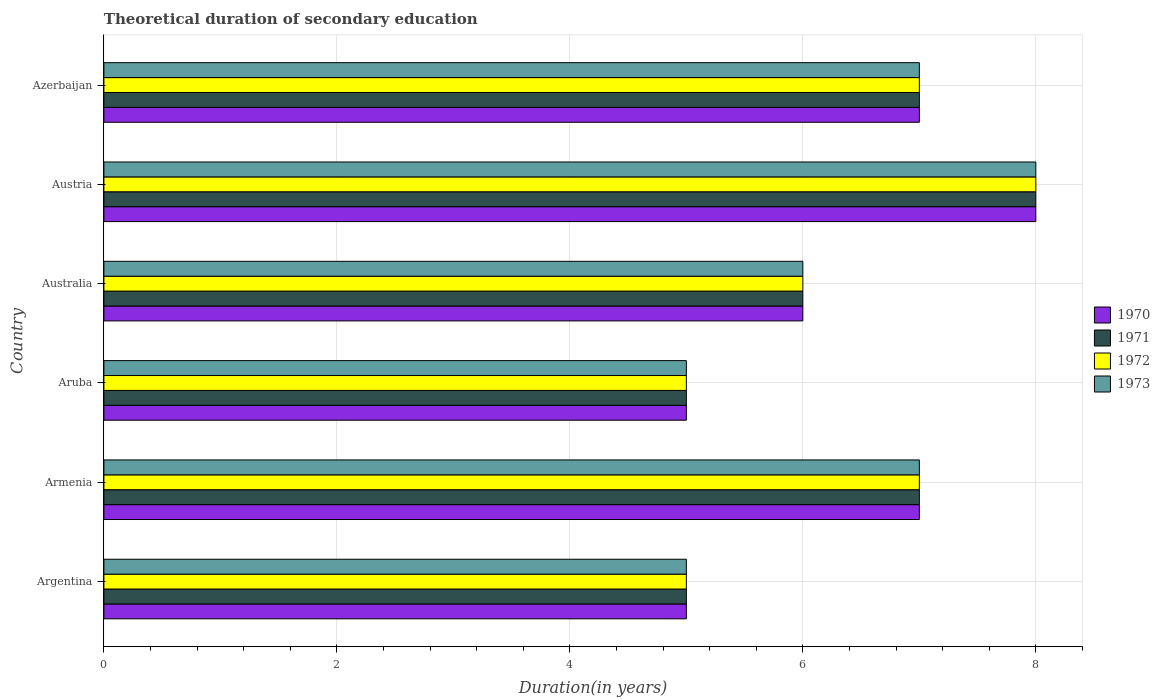How many different coloured bars are there?
Ensure brevity in your answer.  4. How many groups of bars are there?
Ensure brevity in your answer.  6. Are the number of bars on each tick of the Y-axis equal?
Your answer should be very brief. Yes. How many bars are there on the 6th tick from the top?
Your answer should be very brief. 4. What is the label of the 5th group of bars from the top?
Ensure brevity in your answer.  Armenia. In how many cases, is the number of bars for a given country not equal to the number of legend labels?
Your response must be concise. 0. Across all countries, what is the maximum total theoretical duration of secondary education in 1971?
Your response must be concise. 8. Across all countries, what is the minimum total theoretical duration of secondary education in 1971?
Your answer should be very brief. 5. In which country was the total theoretical duration of secondary education in 1971 maximum?
Make the answer very short. Austria. What is the average total theoretical duration of secondary education in 1972 per country?
Your answer should be very brief. 6.33. What is the difference between the total theoretical duration of secondary education in 1970 and total theoretical duration of secondary education in 1972 in Armenia?
Give a very brief answer. 0. What is the ratio of the total theoretical duration of secondary education in 1971 in Austria to that in Azerbaijan?
Give a very brief answer. 1.14. Is the total theoretical duration of secondary education in 1973 in Armenia less than that in Australia?
Make the answer very short. No. In how many countries, is the total theoretical duration of secondary education in 1972 greater than the average total theoretical duration of secondary education in 1972 taken over all countries?
Keep it short and to the point. 3. Is it the case that in every country, the sum of the total theoretical duration of secondary education in 1970 and total theoretical duration of secondary education in 1973 is greater than the sum of total theoretical duration of secondary education in 1971 and total theoretical duration of secondary education in 1972?
Provide a succinct answer. No. What does the 1st bar from the bottom in Armenia represents?
Your response must be concise. 1970. How many bars are there?
Make the answer very short. 24. Are all the bars in the graph horizontal?
Keep it short and to the point. Yes. What is the difference between two consecutive major ticks on the X-axis?
Provide a succinct answer. 2. Does the graph contain any zero values?
Your response must be concise. No. Where does the legend appear in the graph?
Offer a terse response. Center right. How many legend labels are there?
Your answer should be very brief. 4. What is the title of the graph?
Make the answer very short. Theoretical duration of secondary education. Does "1960" appear as one of the legend labels in the graph?
Provide a succinct answer. No. What is the label or title of the X-axis?
Your answer should be very brief. Duration(in years). What is the Duration(in years) in 1971 in Argentina?
Offer a very short reply. 5. What is the Duration(in years) in 1973 in Argentina?
Your response must be concise. 5. What is the Duration(in years) of 1971 in Armenia?
Provide a short and direct response. 7. What is the Duration(in years) of 1972 in Armenia?
Make the answer very short. 7. What is the Duration(in years) of 1973 in Armenia?
Your answer should be very brief. 7. What is the Duration(in years) of 1973 in Aruba?
Provide a succinct answer. 5. What is the Duration(in years) of 1970 in Australia?
Your response must be concise. 6. What is the Duration(in years) in 1971 in Australia?
Your answer should be compact. 6. What is the Duration(in years) in 1973 in Australia?
Your response must be concise. 6. What is the Duration(in years) of 1970 in Austria?
Your answer should be very brief. 8. What is the Duration(in years) in 1972 in Austria?
Your answer should be very brief. 8. What is the Duration(in years) of 1971 in Azerbaijan?
Ensure brevity in your answer.  7. What is the Duration(in years) in 1972 in Azerbaijan?
Ensure brevity in your answer.  7. What is the total Duration(in years) in 1970 in the graph?
Provide a short and direct response. 38. What is the total Duration(in years) in 1971 in the graph?
Provide a succinct answer. 38. What is the total Duration(in years) of 1973 in the graph?
Offer a very short reply. 38. What is the difference between the Duration(in years) in 1970 in Argentina and that in Armenia?
Offer a very short reply. -2. What is the difference between the Duration(in years) in 1971 in Argentina and that in Armenia?
Your answer should be compact. -2. What is the difference between the Duration(in years) of 1973 in Argentina and that in Armenia?
Offer a terse response. -2. What is the difference between the Duration(in years) in 1972 in Argentina and that in Aruba?
Ensure brevity in your answer.  0. What is the difference between the Duration(in years) of 1973 in Argentina and that in Aruba?
Ensure brevity in your answer.  0. What is the difference between the Duration(in years) in 1970 in Argentina and that in Australia?
Keep it short and to the point. -1. What is the difference between the Duration(in years) of 1971 in Argentina and that in Austria?
Provide a short and direct response. -3. What is the difference between the Duration(in years) of 1971 in Argentina and that in Azerbaijan?
Offer a terse response. -2. What is the difference between the Duration(in years) of 1972 in Armenia and that in Aruba?
Offer a terse response. 2. What is the difference between the Duration(in years) in 1970 in Armenia and that in Australia?
Make the answer very short. 1. What is the difference between the Duration(in years) of 1972 in Armenia and that in Australia?
Give a very brief answer. 1. What is the difference between the Duration(in years) in 1973 in Armenia and that in Australia?
Keep it short and to the point. 1. What is the difference between the Duration(in years) in 1971 in Armenia and that in Austria?
Provide a short and direct response. -1. What is the difference between the Duration(in years) of 1973 in Armenia and that in Azerbaijan?
Your response must be concise. 0. What is the difference between the Duration(in years) of 1972 in Aruba and that in Australia?
Offer a terse response. -1. What is the difference between the Duration(in years) in 1973 in Aruba and that in Australia?
Keep it short and to the point. -1. What is the difference between the Duration(in years) of 1970 in Aruba and that in Azerbaijan?
Offer a very short reply. -2. What is the difference between the Duration(in years) in 1973 in Australia and that in Austria?
Give a very brief answer. -2. What is the difference between the Duration(in years) of 1970 in Australia and that in Azerbaijan?
Offer a terse response. -1. What is the difference between the Duration(in years) of 1971 in Australia and that in Azerbaijan?
Give a very brief answer. -1. What is the difference between the Duration(in years) of 1972 in Australia and that in Azerbaijan?
Make the answer very short. -1. What is the difference between the Duration(in years) in 1973 in Australia and that in Azerbaijan?
Offer a terse response. -1. What is the difference between the Duration(in years) in 1971 in Austria and that in Azerbaijan?
Your answer should be very brief. 1. What is the difference between the Duration(in years) in 1972 in Austria and that in Azerbaijan?
Provide a short and direct response. 1. What is the difference between the Duration(in years) in 1973 in Austria and that in Azerbaijan?
Make the answer very short. 1. What is the difference between the Duration(in years) of 1971 in Argentina and the Duration(in years) of 1972 in Armenia?
Your response must be concise. -2. What is the difference between the Duration(in years) in 1970 in Argentina and the Duration(in years) in 1972 in Aruba?
Provide a succinct answer. 0. What is the difference between the Duration(in years) in 1970 in Argentina and the Duration(in years) in 1973 in Aruba?
Offer a very short reply. 0. What is the difference between the Duration(in years) of 1971 in Argentina and the Duration(in years) of 1973 in Aruba?
Offer a very short reply. 0. What is the difference between the Duration(in years) of 1972 in Argentina and the Duration(in years) of 1973 in Aruba?
Make the answer very short. 0. What is the difference between the Duration(in years) in 1970 in Argentina and the Duration(in years) in 1972 in Australia?
Your answer should be compact. -1. What is the difference between the Duration(in years) in 1970 in Argentina and the Duration(in years) in 1973 in Australia?
Offer a very short reply. -1. What is the difference between the Duration(in years) in 1971 in Argentina and the Duration(in years) in 1972 in Australia?
Keep it short and to the point. -1. What is the difference between the Duration(in years) of 1971 in Argentina and the Duration(in years) of 1973 in Australia?
Provide a succinct answer. -1. What is the difference between the Duration(in years) of 1970 in Argentina and the Duration(in years) of 1971 in Austria?
Give a very brief answer. -3. What is the difference between the Duration(in years) of 1970 in Argentina and the Duration(in years) of 1973 in Austria?
Provide a succinct answer. -3. What is the difference between the Duration(in years) of 1971 in Argentina and the Duration(in years) of 1973 in Austria?
Your answer should be very brief. -3. What is the difference between the Duration(in years) in 1972 in Argentina and the Duration(in years) in 1973 in Austria?
Your answer should be compact. -3. What is the difference between the Duration(in years) of 1970 in Argentina and the Duration(in years) of 1971 in Azerbaijan?
Offer a terse response. -2. What is the difference between the Duration(in years) of 1970 in Argentina and the Duration(in years) of 1972 in Azerbaijan?
Provide a short and direct response. -2. What is the difference between the Duration(in years) of 1971 in Argentina and the Duration(in years) of 1973 in Azerbaijan?
Your response must be concise. -2. What is the difference between the Duration(in years) of 1972 in Argentina and the Duration(in years) of 1973 in Azerbaijan?
Provide a short and direct response. -2. What is the difference between the Duration(in years) in 1970 in Armenia and the Duration(in years) in 1972 in Aruba?
Ensure brevity in your answer.  2. What is the difference between the Duration(in years) of 1971 in Armenia and the Duration(in years) of 1973 in Aruba?
Ensure brevity in your answer.  2. What is the difference between the Duration(in years) in 1972 in Armenia and the Duration(in years) in 1973 in Aruba?
Make the answer very short. 2. What is the difference between the Duration(in years) in 1970 in Armenia and the Duration(in years) in 1971 in Australia?
Offer a very short reply. 1. What is the difference between the Duration(in years) of 1971 in Armenia and the Duration(in years) of 1972 in Australia?
Keep it short and to the point. 1. What is the difference between the Duration(in years) of 1971 in Armenia and the Duration(in years) of 1973 in Australia?
Your answer should be very brief. 1. What is the difference between the Duration(in years) in 1970 in Armenia and the Duration(in years) in 1973 in Austria?
Ensure brevity in your answer.  -1. What is the difference between the Duration(in years) of 1971 in Armenia and the Duration(in years) of 1972 in Austria?
Keep it short and to the point. -1. What is the difference between the Duration(in years) of 1970 in Armenia and the Duration(in years) of 1972 in Azerbaijan?
Provide a succinct answer. 0. What is the difference between the Duration(in years) in 1970 in Armenia and the Duration(in years) in 1973 in Azerbaijan?
Your answer should be compact. 0. What is the difference between the Duration(in years) in 1971 in Armenia and the Duration(in years) in 1972 in Azerbaijan?
Keep it short and to the point. 0. What is the difference between the Duration(in years) in 1971 in Armenia and the Duration(in years) in 1973 in Azerbaijan?
Offer a very short reply. 0. What is the difference between the Duration(in years) of 1970 in Aruba and the Duration(in years) of 1973 in Australia?
Your response must be concise. -1. What is the difference between the Duration(in years) of 1971 in Aruba and the Duration(in years) of 1972 in Australia?
Offer a terse response. -1. What is the difference between the Duration(in years) in 1971 in Aruba and the Duration(in years) in 1973 in Australia?
Keep it short and to the point. -1. What is the difference between the Duration(in years) in 1972 in Aruba and the Duration(in years) in 1973 in Australia?
Keep it short and to the point. -1. What is the difference between the Duration(in years) of 1970 in Aruba and the Duration(in years) of 1971 in Austria?
Make the answer very short. -3. What is the difference between the Duration(in years) of 1970 in Aruba and the Duration(in years) of 1972 in Austria?
Keep it short and to the point. -3. What is the difference between the Duration(in years) of 1971 in Aruba and the Duration(in years) of 1972 in Austria?
Offer a very short reply. -3. What is the difference between the Duration(in years) of 1970 in Aruba and the Duration(in years) of 1971 in Azerbaijan?
Offer a very short reply. -2. What is the difference between the Duration(in years) in 1970 in Aruba and the Duration(in years) in 1972 in Azerbaijan?
Make the answer very short. -2. What is the difference between the Duration(in years) of 1971 in Aruba and the Duration(in years) of 1972 in Azerbaijan?
Make the answer very short. -2. What is the difference between the Duration(in years) of 1972 in Aruba and the Duration(in years) of 1973 in Azerbaijan?
Provide a succinct answer. -2. What is the difference between the Duration(in years) of 1970 in Australia and the Duration(in years) of 1971 in Austria?
Make the answer very short. -2. What is the difference between the Duration(in years) in 1970 in Australia and the Duration(in years) in 1972 in Austria?
Ensure brevity in your answer.  -2. What is the difference between the Duration(in years) of 1970 in Australia and the Duration(in years) of 1973 in Austria?
Offer a very short reply. -2. What is the difference between the Duration(in years) of 1970 in Australia and the Duration(in years) of 1971 in Azerbaijan?
Offer a very short reply. -1. What is the difference between the Duration(in years) of 1971 in Australia and the Duration(in years) of 1972 in Azerbaijan?
Keep it short and to the point. -1. What is the difference between the Duration(in years) of 1971 in Australia and the Duration(in years) of 1973 in Azerbaijan?
Your answer should be compact. -1. What is the difference between the Duration(in years) in 1972 in Australia and the Duration(in years) in 1973 in Azerbaijan?
Provide a short and direct response. -1. What is the difference between the Duration(in years) of 1970 in Austria and the Duration(in years) of 1972 in Azerbaijan?
Provide a succinct answer. 1. What is the difference between the Duration(in years) in 1970 in Austria and the Duration(in years) in 1973 in Azerbaijan?
Give a very brief answer. 1. What is the difference between the Duration(in years) of 1971 in Austria and the Duration(in years) of 1973 in Azerbaijan?
Provide a short and direct response. 1. What is the difference between the Duration(in years) in 1972 in Austria and the Duration(in years) in 1973 in Azerbaijan?
Your answer should be very brief. 1. What is the average Duration(in years) in 1970 per country?
Give a very brief answer. 6.33. What is the average Duration(in years) of 1971 per country?
Provide a short and direct response. 6.33. What is the average Duration(in years) in 1972 per country?
Provide a short and direct response. 6.33. What is the average Duration(in years) of 1973 per country?
Provide a succinct answer. 6.33. What is the difference between the Duration(in years) in 1970 and Duration(in years) in 1971 in Argentina?
Offer a very short reply. 0. What is the difference between the Duration(in years) of 1970 and Duration(in years) of 1972 in Argentina?
Give a very brief answer. 0. What is the difference between the Duration(in years) of 1970 and Duration(in years) of 1973 in Argentina?
Offer a very short reply. 0. What is the difference between the Duration(in years) of 1971 and Duration(in years) of 1972 in Argentina?
Provide a succinct answer. 0. What is the difference between the Duration(in years) in 1972 and Duration(in years) in 1973 in Argentina?
Ensure brevity in your answer.  0. What is the difference between the Duration(in years) of 1970 and Duration(in years) of 1973 in Armenia?
Provide a succinct answer. 0. What is the difference between the Duration(in years) of 1971 and Duration(in years) of 1972 in Armenia?
Provide a succinct answer. 0. What is the difference between the Duration(in years) of 1971 and Duration(in years) of 1973 in Armenia?
Offer a terse response. 0. What is the difference between the Duration(in years) in 1972 and Duration(in years) in 1973 in Armenia?
Your response must be concise. 0. What is the difference between the Duration(in years) in 1970 and Duration(in years) in 1971 in Aruba?
Provide a short and direct response. 0. What is the difference between the Duration(in years) in 1970 and Duration(in years) in 1972 in Aruba?
Provide a short and direct response. 0. What is the difference between the Duration(in years) in 1970 and Duration(in years) in 1973 in Aruba?
Your response must be concise. 0. What is the difference between the Duration(in years) of 1971 and Duration(in years) of 1973 in Aruba?
Offer a terse response. 0. What is the difference between the Duration(in years) of 1970 and Duration(in years) of 1973 in Australia?
Provide a succinct answer. 0. What is the difference between the Duration(in years) of 1971 and Duration(in years) of 1972 in Australia?
Your answer should be very brief. 0. What is the difference between the Duration(in years) in 1972 and Duration(in years) in 1973 in Australia?
Make the answer very short. 0. What is the difference between the Duration(in years) of 1970 and Duration(in years) of 1971 in Austria?
Keep it short and to the point. 0. What is the difference between the Duration(in years) in 1970 and Duration(in years) in 1973 in Austria?
Keep it short and to the point. 0. What is the difference between the Duration(in years) in 1971 and Duration(in years) in 1972 in Austria?
Keep it short and to the point. 0. What is the difference between the Duration(in years) in 1971 and Duration(in years) in 1973 in Austria?
Give a very brief answer. 0. What is the difference between the Duration(in years) in 1971 and Duration(in years) in 1973 in Azerbaijan?
Make the answer very short. 0. What is the ratio of the Duration(in years) in 1970 in Argentina to that in Armenia?
Make the answer very short. 0.71. What is the ratio of the Duration(in years) in 1971 in Argentina to that in Armenia?
Make the answer very short. 0.71. What is the ratio of the Duration(in years) in 1973 in Argentina to that in Armenia?
Offer a very short reply. 0.71. What is the ratio of the Duration(in years) in 1970 in Argentina to that in Aruba?
Make the answer very short. 1. What is the ratio of the Duration(in years) in 1971 in Argentina to that in Aruba?
Your response must be concise. 1. What is the ratio of the Duration(in years) of 1972 in Argentina to that in Aruba?
Offer a terse response. 1. What is the ratio of the Duration(in years) in 1973 in Argentina to that in Aruba?
Ensure brevity in your answer.  1. What is the ratio of the Duration(in years) of 1972 in Argentina to that in Australia?
Provide a succinct answer. 0.83. What is the ratio of the Duration(in years) of 1973 in Argentina to that in Australia?
Your answer should be compact. 0.83. What is the ratio of the Duration(in years) of 1970 in Argentina to that in Austria?
Provide a succinct answer. 0.62. What is the ratio of the Duration(in years) of 1972 in Argentina to that in Austria?
Ensure brevity in your answer.  0.62. What is the ratio of the Duration(in years) of 1973 in Argentina to that in Austria?
Offer a very short reply. 0.62. What is the ratio of the Duration(in years) in 1972 in Argentina to that in Azerbaijan?
Make the answer very short. 0.71. What is the ratio of the Duration(in years) of 1973 in Argentina to that in Azerbaijan?
Keep it short and to the point. 0.71. What is the ratio of the Duration(in years) in 1970 in Armenia to that in Aruba?
Make the answer very short. 1.4. What is the ratio of the Duration(in years) in 1971 in Armenia to that in Aruba?
Your answer should be compact. 1.4. What is the ratio of the Duration(in years) of 1972 in Armenia to that in Aruba?
Your answer should be compact. 1.4. What is the ratio of the Duration(in years) of 1973 in Armenia to that in Aruba?
Ensure brevity in your answer.  1.4. What is the ratio of the Duration(in years) of 1970 in Armenia to that in Australia?
Provide a short and direct response. 1.17. What is the ratio of the Duration(in years) in 1971 in Armenia to that in Australia?
Make the answer very short. 1.17. What is the ratio of the Duration(in years) of 1973 in Armenia to that in Australia?
Keep it short and to the point. 1.17. What is the ratio of the Duration(in years) in 1971 in Armenia to that in Austria?
Provide a succinct answer. 0.88. What is the ratio of the Duration(in years) of 1972 in Armenia to that in Austria?
Keep it short and to the point. 0.88. What is the ratio of the Duration(in years) of 1973 in Armenia to that in Austria?
Keep it short and to the point. 0.88. What is the ratio of the Duration(in years) of 1970 in Armenia to that in Azerbaijan?
Ensure brevity in your answer.  1. What is the ratio of the Duration(in years) of 1972 in Armenia to that in Azerbaijan?
Provide a succinct answer. 1. What is the ratio of the Duration(in years) in 1970 in Aruba to that in Australia?
Offer a very short reply. 0.83. What is the ratio of the Duration(in years) in 1971 in Aruba to that in Australia?
Your response must be concise. 0.83. What is the ratio of the Duration(in years) of 1970 in Aruba to that in Austria?
Make the answer very short. 0.62. What is the ratio of the Duration(in years) in 1973 in Aruba to that in Austria?
Offer a terse response. 0.62. What is the ratio of the Duration(in years) in 1971 in Aruba to that in Azerbaijan?
Offer a terse response. 0.71. What is the ratio of the Duration(in years) in 1973 in Australia to that in Austria?
Your answer should be very brief. 0.75. What is the ratio of the Duration(in years) in 1971 in Australia to that in Azerbaijan?
Your answer should be very brief. 0.86. What is the ratio of the Duration(in years) of 1970 in Austria to that in Azerbaijan?
Your answer should be very brief. 1.14. What is the ratio of the Duration(in years) in 1971 in Austria to that in Azerbaijan?
Make the answer very short. 1.14. What is the ratio of the Duration(in years) in 1972 in Austria to that in Azerbaijan?
Offer a very short reply. 1.14. What is the difference between the highest and the second highest Duration(in years) of 1970?
Make the answer very short. 1. What is the difference between the highest and the second highest Duration(in years) of 1971?
Provide a succinct answer. 1. What is the difference between the highest and the second highest Duration(in years) of 1973?
Ensure brevity in your answer.  1. What is the difference between the highest and the lowest Duration(in years) of 1971?
Your response must be concise. 3. 